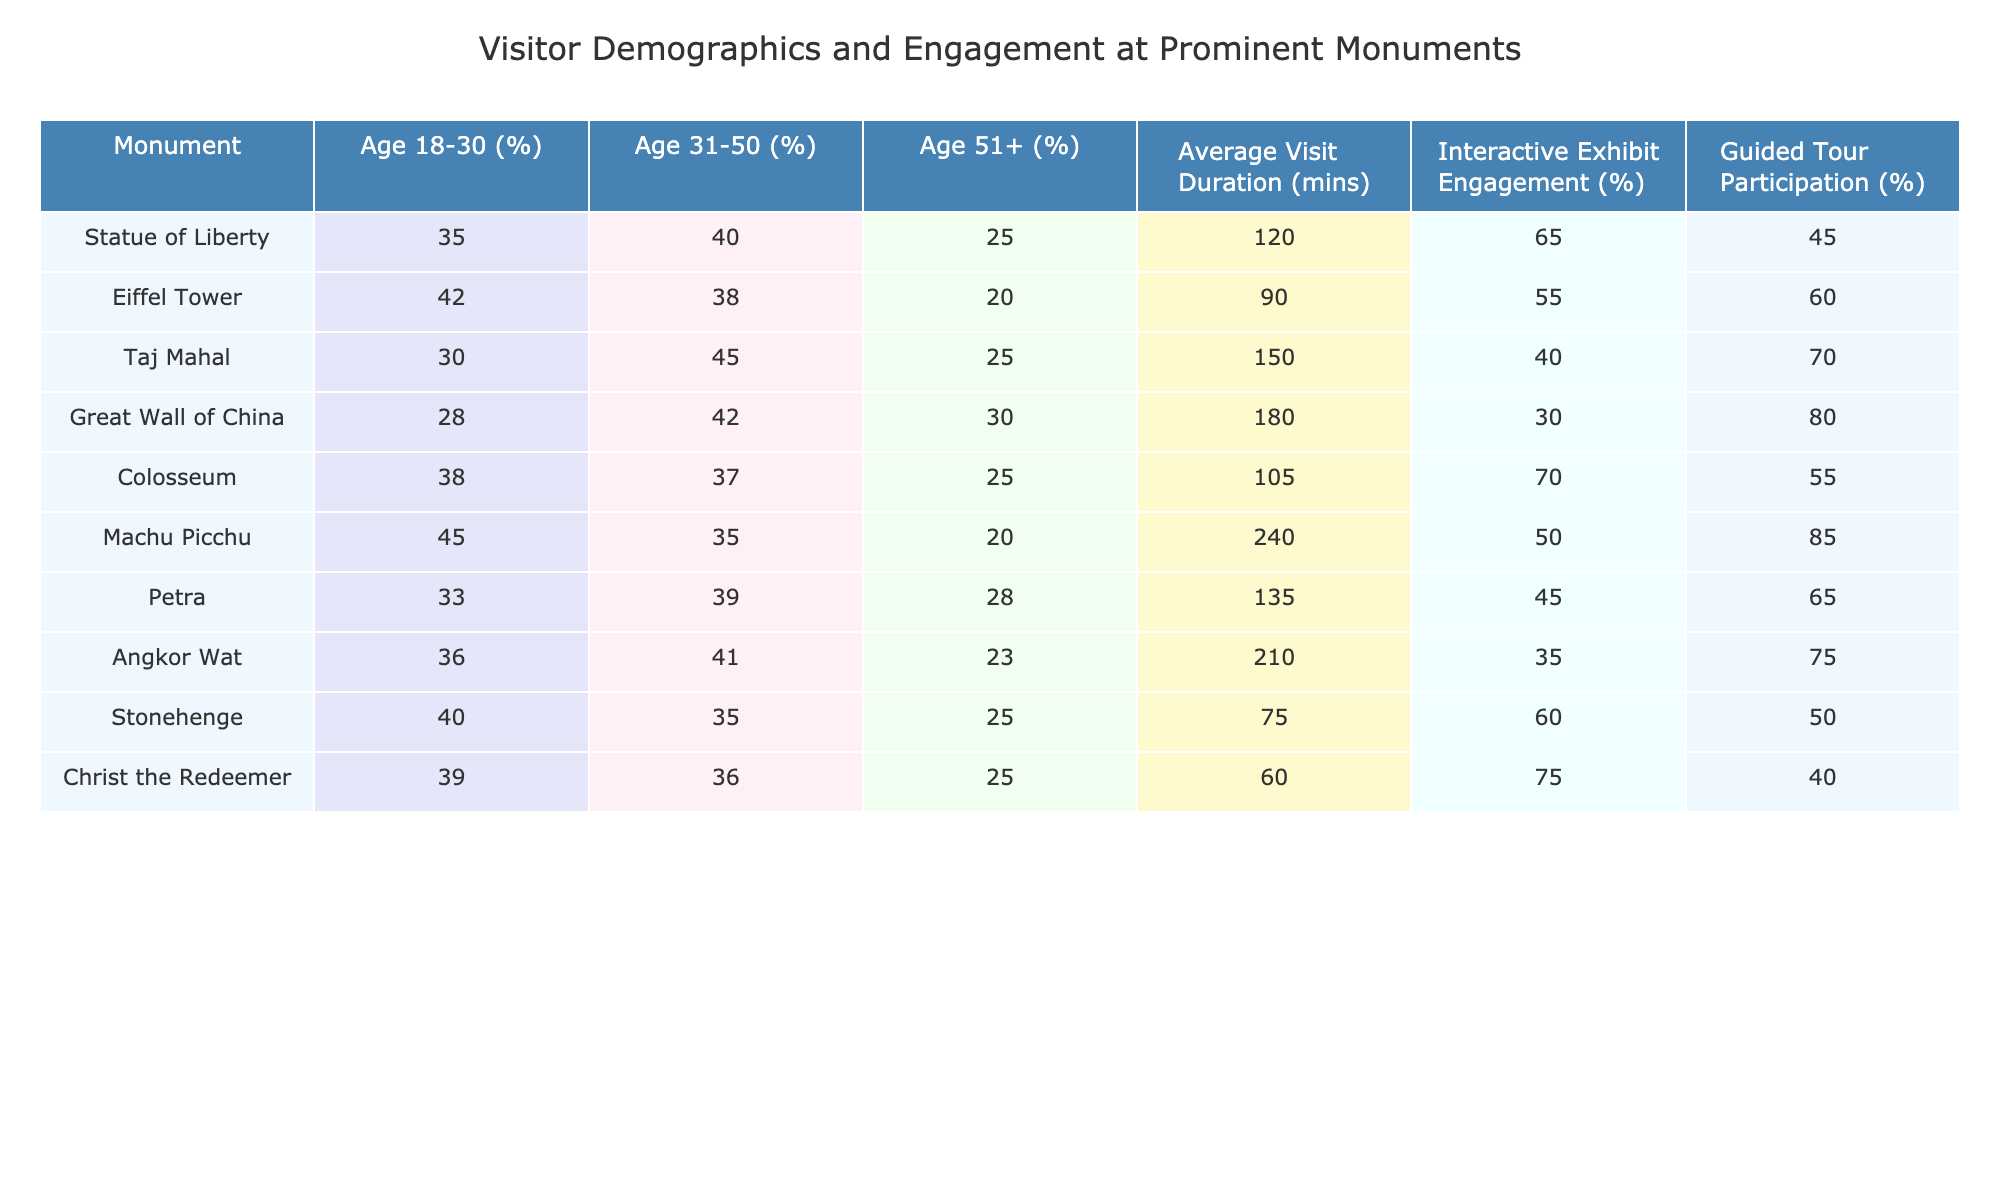What percentage of 18-30 year olds visit the Taj Mahal? The data for the Taj Mahal shows that 30% of its visitors fall into the 18-30 age group.
Answer: 30% Which monument has the highest percentage of visitors aged 31-50? The Eiffel Tower has 38% of its visitors aged 31-50, which is higher than any other monument listed.
Answer: Eiffel Tower What is the average visit duration for the Great Wall of China? The average visit duration for the Great Wall of China is 180 minutes as stated in the table.
Answer: 180 minutes Which monument has the lowest average visit duration? By reviewing the table, we see that Christ the Redeemer has the lowest average visit duration at 60 minutes.
Answer: Christ the Redeemer What is the total percentage of visitors aged 51 and older for the Colosseum and the Statue of Liberty? The Colosseum has 25% and the Statue of Liberty has 25% of visitors aged 51 and older. Sum of these percentages is 25 + 25 = 50%.
Answer: 50% Is the percentage of guided tour participation at Machu Picchu higher than that of the Eiffel Tower? Machu Picchu has 85% guided tour participation, while the Eiffel Tower has 60%. Since 85% is greater than 60%, the statement is true.
Answer: Yes Which age group engages more with interactive exhibits at the Colosseum compared to the Taj Mahal? The Colosseum's interactive exhibit engagement is at 70% while the Taj Mahal's is at 40%. This shows that engagement is higher at the Colosseum for the same metric.
Answer: Age group engagement is higher at the Colosseum If we compare the average visit duration of the Eiffel Tower and Stonehenge, which one has a longer duration, and by how much? The Eiffel Tower has an average visit duration of 90 minutes, while Stonehenge has 75 minutes. The difference is 90 - 75 = 15 minutes.
Answer: Eiffel Tower is longer by 15 minutes Considering the monuments, are more than half of the visitors at Angkor Wat engaged with interactive exhibits? Angkor Wat has an engagement level of 35% for interactive exhibits, which is less than half (50%). Therefore, this statement is false.
Answer: No How does the average visit duration of the Taj Mahal compare with that of the Machu Picchu? The Taj Mahal averages 150 minutes while Machu Picchu averages 240 minutes. The difference is 240 - 150 = 90 minutes, indicating that Machu Picchu has a longer duration.
Answer: Machu Picchu is longer by 90 minutes 